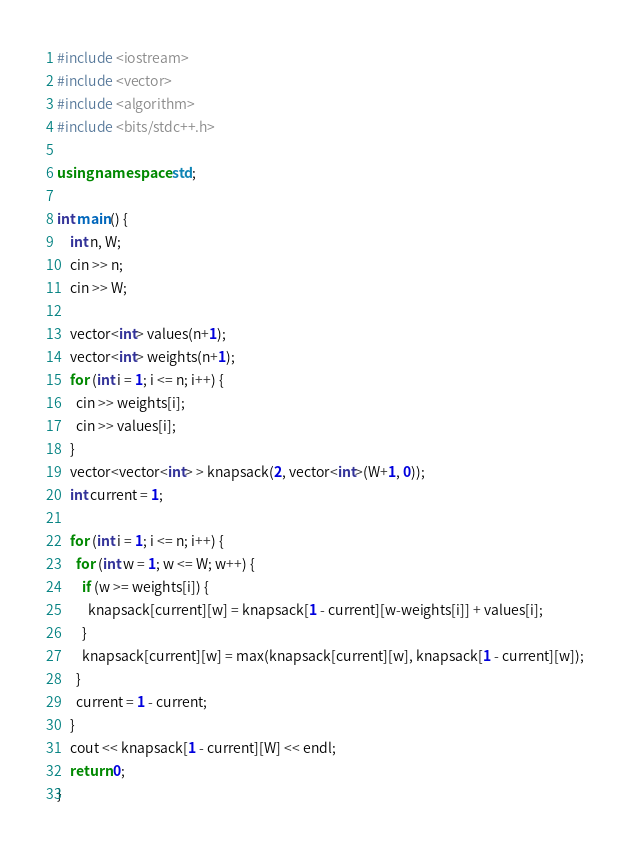<code> <loc_0><loc_0><loc_500><loc_500><_C++_>#include <iostream>
#include <vector>
#include <algorithm>
#include <bits/stdc++.h>

using namespace std;

int main() {
    int n, W;
    cin >> n;
    cin >> W;

    vector<int> values(n+1);
    vector<int> weights(n+1);
    for (int i = 1; i <= n; i++) {
      cin >> weights[i];
      cin >> values[i];
    }
    vector<vector<int> > knapsack(2, vector<int>(W+1, 0));
    int current = 1;

    for (int i = 1; i <= n; i++) {
      for (int w = 1; w <= W; w++) {
        if (w >= weights[i]) {
          knapsack[current][w] = knapsack[1 - current][w-weights[i]] + values[i];
        }
        knapsack[current][w] = max(knapsack[current][w], knapsack[1 - current][w]);
      }
      current = 1 - current;
    }
    cout << knapsack[1 - current][W] << endl;
    return 0;
}
</code> 